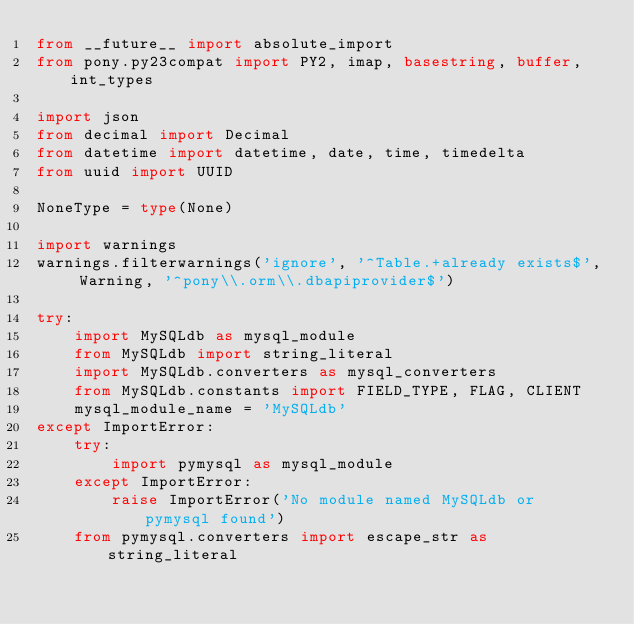<code> <loc_0><loc_0><loc_500><loc_500><_Python_>from __future__ import absolute_import
from pony.py23compat import PY2, imap, basestring, buffer, int_types

import json
from decimal import Decimal
from datetime import datetime, date, time, timedelta
from uuid import UUID

NoneType = type(None)

import warnings
warnings.filterwarnings('ignore', '^Table.+already exists$', Warning, '^pony\\.orm\\.dbapiprovider$')

try:
    import MySQLdb as mysql_module
    from MySQLdb import string_literal
    import MySQLdb.converters as mysql_converters
    from MySQLdb.constants import FIELD_TYPE, FLAG, CLIENT
    mysql_module_name = 'MySQLdb'
except ImportError:
    try:
        import pymysql as mysql_module
    except ImportError:
        raise ImportError('No module named MySQLdb or pymysql found')
    from pymysql.converters import escape_str as string_literal</code> 